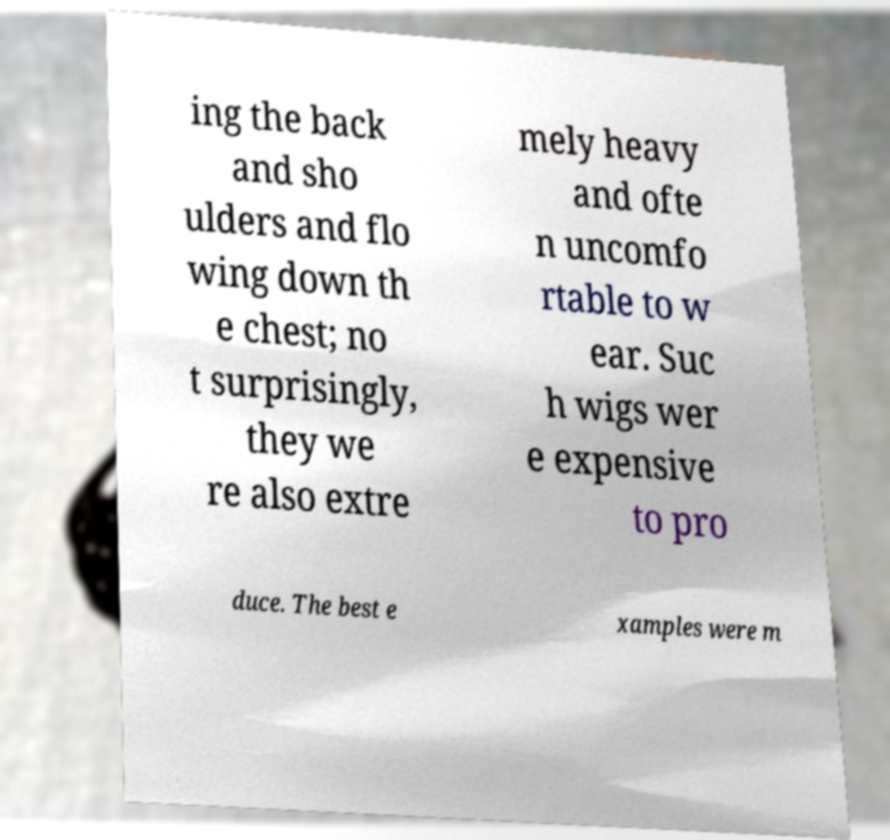Can you read and provide the text displayed in the image?This photo seems to have some interesting text. Can you extract and type it out for me? ing the back and sho ulders and flo wing down th e chest; no t surprisingly, they we re also extre mely heavy and ofte n uncomfo rtable to w ear. Suc h wigs wer e expensive to pro duce. The best e xamples were m 